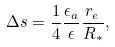Convert formula to latex. <formula><loc_0><loc_0><loc_500><loc_500>\Delta s = \frac { 1 } { 4 } \frac { \epsilon _ { a } } { \epsilon } \frac { r _ { e } } { R _ { * } } ,</formula> 